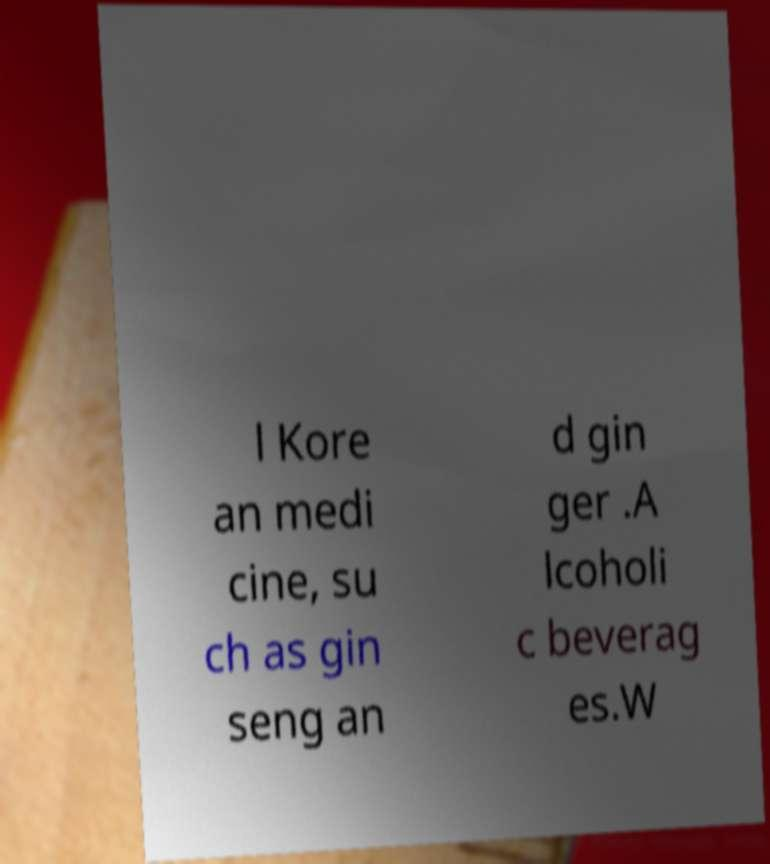Could you assist in decoding the text presented in this image and type it out clearly? l Kore an medi cine, su ch as gin seng an d gin ger .A lcoholi c beverag es.W 